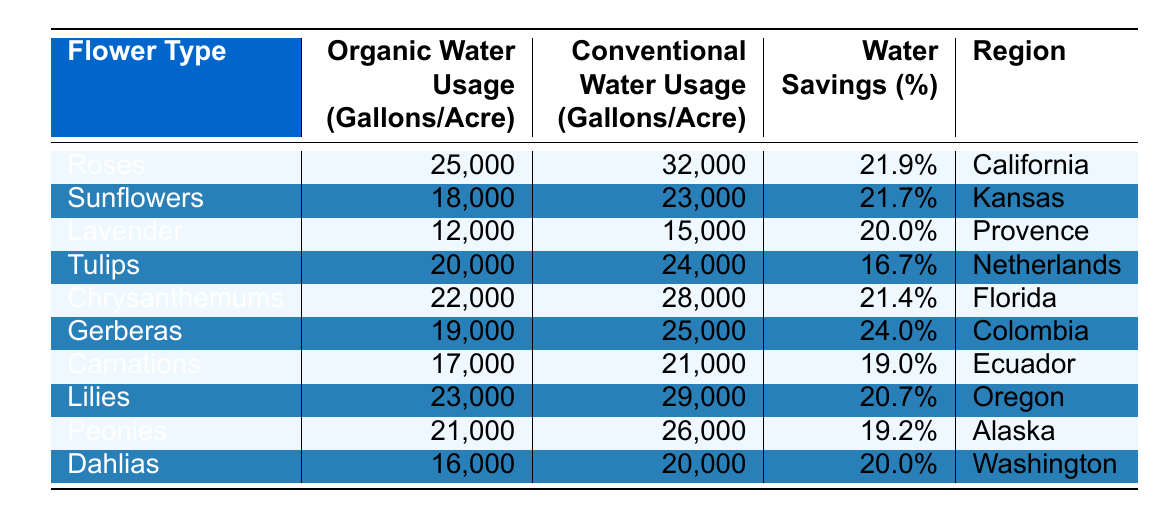What is the organic water usage for Gerberas? Gerberas have an organic water usage of 19,000 gallons per acre as listed in the table.
Answer: 19,000 gallons Which flower type has the highest water savings percentage? By reviewing the table, Gerberas have the highest water savings percentage at 24.0%.
Answer: 24.0% What is the difference in water usage for Tulips between organic and conventional methods? The water usage for Tulips is 20,000 gallons for organic and 24,000 gallons for conventional. The difference is 24,000 - 20,000 = 4,000 gallons.
Answer: 4,000 gallons Are Carnations more water-efficient than Lilies in terms of water savings? Carnations have a water savings of 19.0%, while Lilies have a water savings of 20.7%. Therefore, Carnations are less water-efficient than Lilies.
Answer: No What is the average organic water usage among all flower types listed? The sum of organic water usage is (25000 + 18000 + 12000 + 20000 + 22000 + 19000 + 17000 + 23000 + 21000 + 16000) = 1,890,000 gallons. There are 10 flower types, so the average is 1,890,000 / 10 = 18900 gallons.
Answer: 18,900 gallons Which region has the lowest conventional water usage for flower farming? Among the regions listed, Lavender from Provence has the lowest conventional water usage of 15,000 gallons per acre.
Answer: Provence What percentage water savings do Sunflowers achieve compared to conventional methods? The table states that Sunflowers achieve water savings of 21.7% compared to conventional methods.
Answer: 21.7% Which flower uses the most water in conventional farming methods? The table shows that Roses have the highest conventional water usage at 32,000 gallons per acre.
Answer: Roses If we compare the organic water usage of Dahlias and Carnations, which one uses more water? Dahlias use 16,000 gallons per acre, while Carnations use 17,000 gallons per acre. Thus, Carnations use more water.
Answer: Carnations What is the total water usage for all flowers in conventional farming? The total for conventional farming is (32000 + 23000 + 15000 + 24000 + 28000 + 25000 + 21000 + 29000 + 26000 + 20000) = 2,610,000 gallons.
Answer: 2,610,000 gallons 